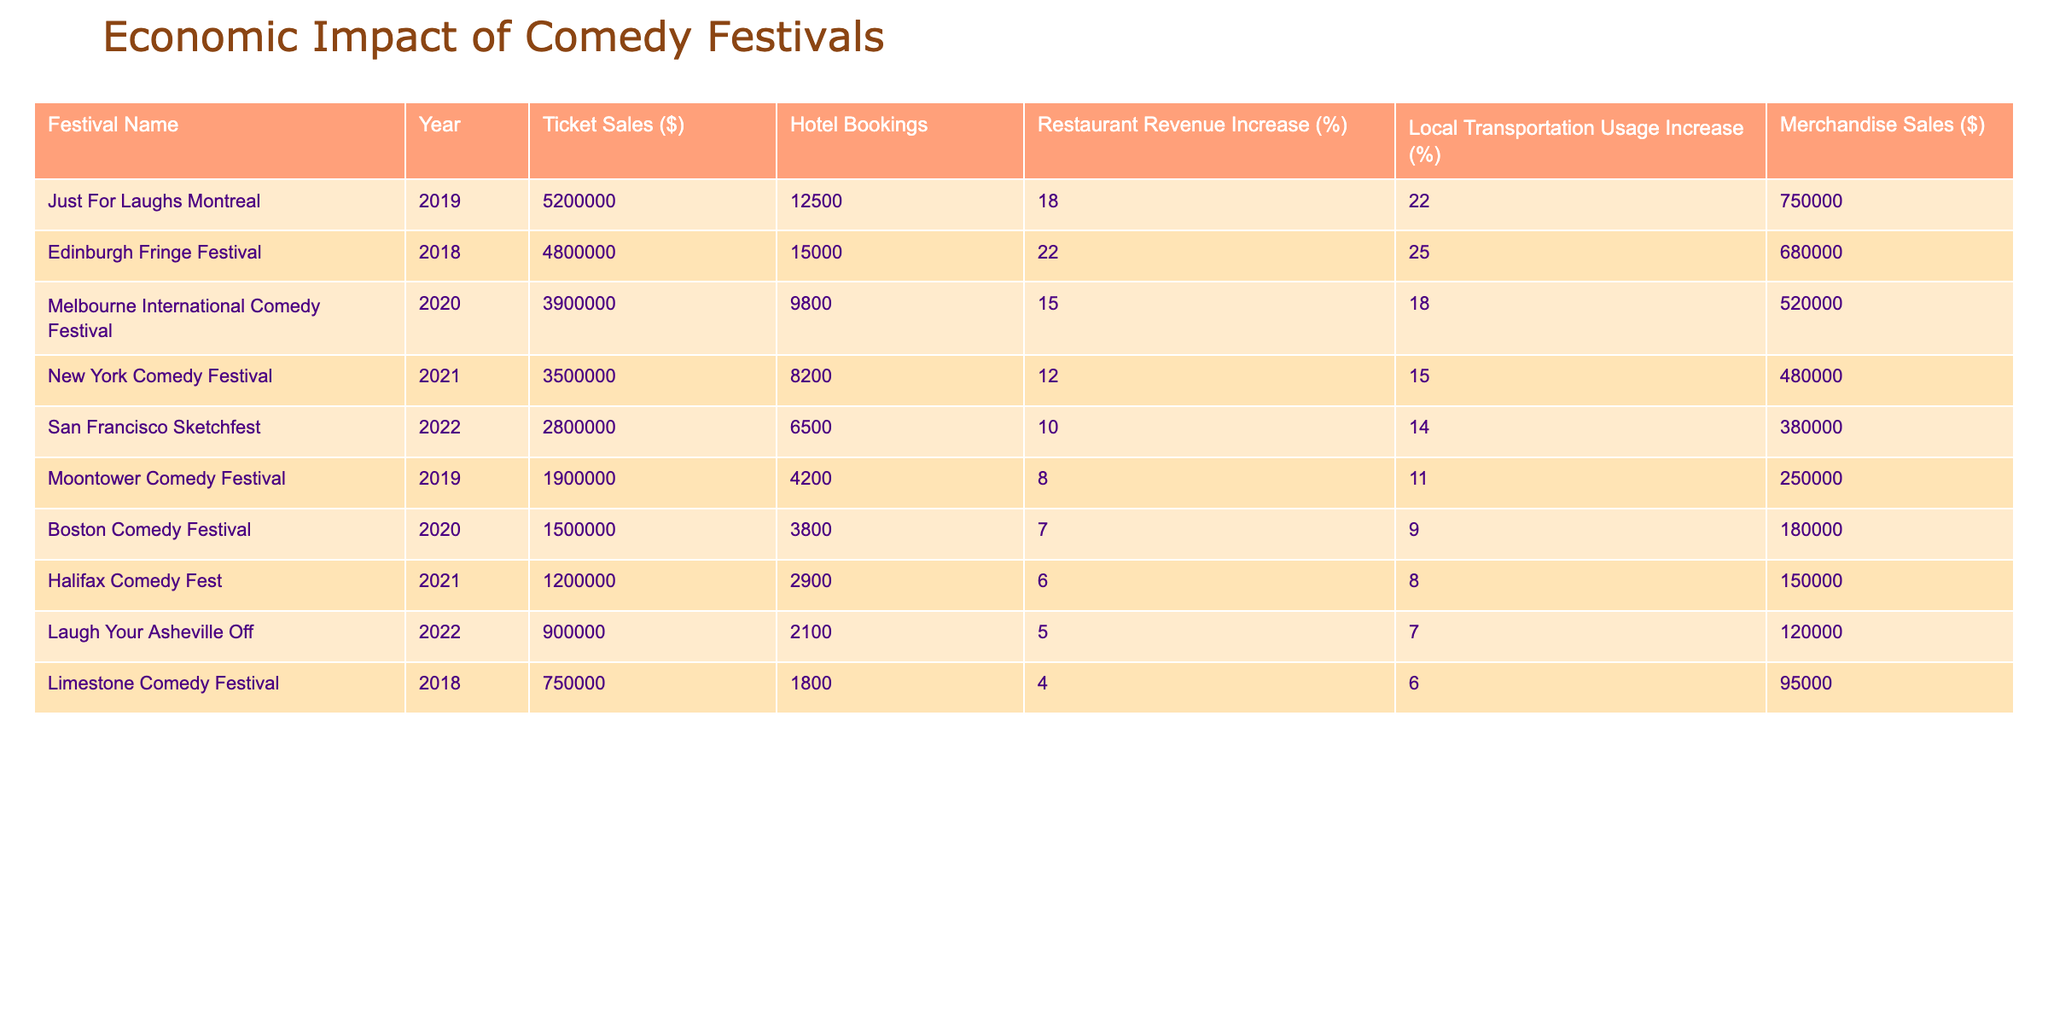What is the ticket sales amount for the Edinburgh Fringe Festival? The table shows that the ticket sales for the Edinburgh Fringe Festival in 2018 are listed as $4,800,000.
Answer: $4,800,000 Which comedy festival had the highest increase in restaurant revenue percentage? By comparing the 'Restaurant Revenue Increase (%)' column, the Edinburgh Fringe Festival has the highest percentage at 22%.
Answer: 22% What are the total hotel bookings for all festivals combined? To find the total hotel bookings, add each festival's hotel bookings: 12500 + 15000 + 9800 + 8200 + 6500 + 4200 + 3800 + 2900 + 2100 + 1800 =  60100.
Answer: 60100 Did the Moontower Comedy Festival contribute more to local transportation usage than the Halifax Comedy Fest? Comparing the 'Local Transportation Usage Increase (%)' for Moontower (11%) and Halifax (8%), Moontower had a higher percentage.
Answer: Yes What is the average merchandise sales of all the festivals listed? To find the average merchandise sales, add all merchandise sales: 750000 + 680000 + 520000 + 480000 + 380000 + 250000 + 180000 + 150000 + 120000 + 95000 = 3130000. Then, divide by the count of festivals (10): 3130000 / 10 = 313000.
Answer: 313000 Which festival had the lowest ticket sales, and what was the amount? From the 'Ticket Sales ($)' column, the festival with the lowest ticket sales is the Laugh Your Asheville Off with $900,000.
Answer: Laugh Your Asheville Off, $900,000 What is the difference in ticket sales between Just For Laughs Montreal and New York Comedy Festival? The ticket sales for Just For Laughs Montreal are $5,200,000, and for New York Comedy Festival, it is $3,500,000. The difference is $5,200,000 - $3,500,000 = $1,700,000.
Answer: $1,700,000 How much did restaurant revenue increase for the Melbourne International Comedy Festival? The table shows that the restaurant revenue increase for the Melbourne International Comedy Festival is 15%.
Answer: 15% Which comedy festival had more hotel bookings, Moontower Comedy Festival or Boston Comedy Festival? Moontower had 4200 hotel bookings, and Boston had 3800 hotel bookings. Therefore, Moontower had more.
Answer: Moontower Comedy Festival What is the total revenue from merchandise sales for festivals held in 2019? The relevant festivals in 2019 are Just For Laughs Montreal ($750,000) and Moontower Comedy Festival ($250,000). Their total is $750,000 + $250,000 = $1,000,000.
Answer: $1,000,000 